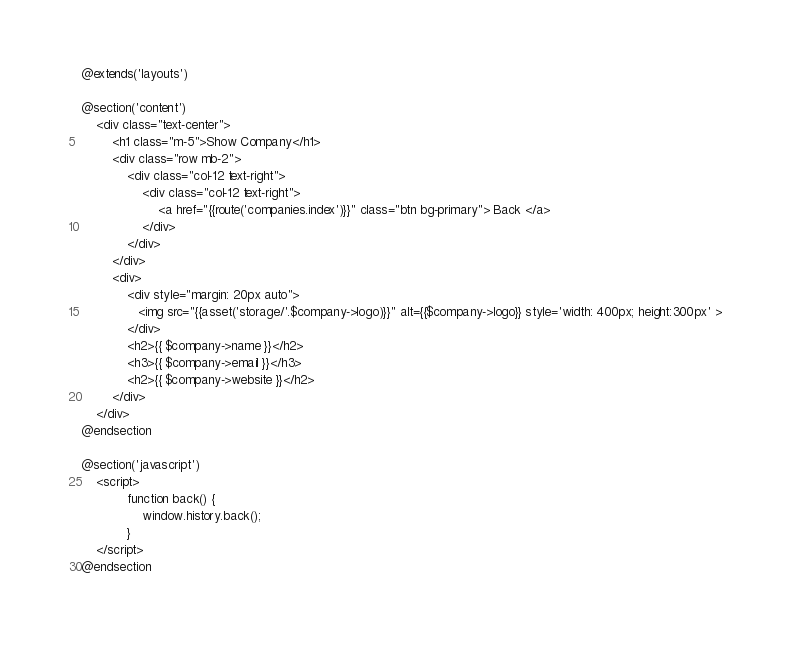<code> <loc_0><loc_0><loc_500><loc_500><_PHP_>@extends('layouts')

@section('content')
    <div class="text-center">
        <h1 class="m-5">Show Company</h1>
        <div class="row mb-2">
            <div class="col-12 text-right">
                <div class="col-12 text-right">
                    <a href="{{route('companies.index')}}" class="btn bg-primary"> Back </a>
                </div>
            </div>
        </div>
        <div>
            <div style="margin: 20px auto">
               <img src="{{asset('storage/'.$company->logo)}}" alt={{$company->logo}} style='width: 400px; height:300px' >
            </div>
            <h2>{{ $company->name }}</h2>
            <h3>{{ $company->email }}</h3>
            <h2>{{ $company->website }}</h2>
        </div>
    </div>
@endsection

@section('javascript')
    <script>
            function back() {
                window.history.back();
            }
    </script>
@endsection
</code> 